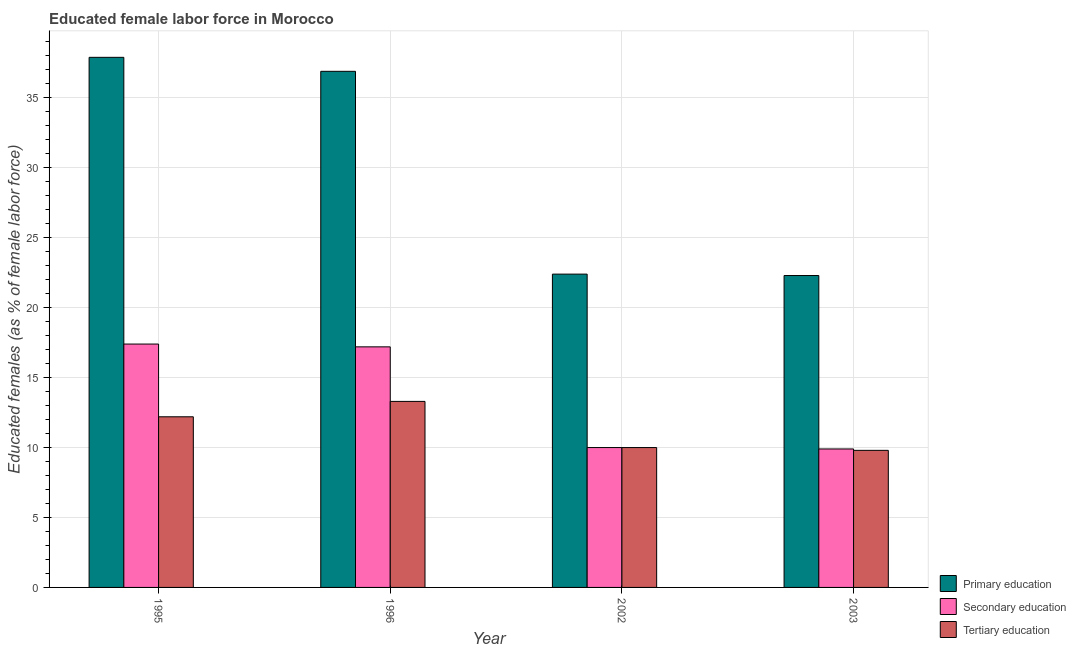How many different coloured bars are there?
Keep it short and to the point. 3. Are the number of bars on each tick of the X-axis equal?
Provide a succinct answer. Yes. How many bars are there on the 3rd tick from the left?
Provide a short and direct response. 3. In how many cases, is the number of bars for a given year not equal to the number of legend labels?
Provide a succinct answer. 0. What is the percentage of female labor force who received primary education in 1996?
Ensure brevity in your answer.  36.9. Across all years, what is the maximum percentage of female labor force who received tertiary education?
Provide a short and direct response. 13.3. Across all years, what is the minimum percentage of female labor force who received secondary education?
Give a very brief answer. 9.9. In which year was the percentage of female labor force who received tertiary education maximum?
Offer a very short reply. 1996. What is the total percentage of female labor force who received secondary education in the graph?
Your answer should be compact. 54.5. What is the difference between the percentage of female labor force who received tertiary education in 2002 and that in 2003?
Provide a succinct answer. 0.2. What is the difference between the percentage of female labor force who received primary education in 1996 and the percentage of female labor force who received secondary education in 2003?
Your response must be concise. 14.6. What is the average percentage of female labor force who received secondary education per year?
Give a very brief answer. 13.63. What is the ratio of the percentage of female labor force who received tertiary education in 1996 to that in 2003?
Offer a terse response. 1.36. Is the percentage of female labor force who received tertiary education in 1996 less than that in 2003?
Offer a terse response. No. What is the difference between the highest and the lowest percentage of female labor force who received secondary education?
Your answer should be compact. 7.5. In how many years, is the percentage of female labor force who received primary education greater than the average percentage of female labor force who received primary education taken over all years?
Offer a very short reply. 2. Is the sum of the percentage of female labor force who received primary education in 2002 and 2003 greater than the maximum percentage of female labor force who received tertiary education across all years?
Offer a terse response. Yes. What does the 3rd bar from the left in 2002 represents?
Your answer should be compact. Tertiary education. What does the 2nd bar from the right in 1996 represents?
Make the answer very short. Secondary education. How many bars are there?
Ensure brevity in your answer.  12. Does the graph contain grids?
Ensure brevity in your answer.  Yes. Where does the legend appear in the graph?
Your response must be concise. Bottom right. How are the legend labels stacked?
Ensure brevity in your answer.  Vertical. What is the title of the graph?
Give a very brief answer. Educated female labor force in Morocco. What is the label or title of the Y-axis?
Your answer should be very brief. Educated females (as % of female labor force). What is the Educated females (as % of female labor force) in Primary education in 1995?
Give a very brief answer. 37.9. What is the Educated females (as % of female labor force) of Secondary education in 1995?
Offer a terse response. 17.4. What is the Educated females (as % of female labor force) of Tertiary education in 1995?
Provide a short and direct response. 12.2. What is the Educated females (as % of female labor force) in Primary education in 1996?
Your answer should be compact. 36.9. What is the Educated females (as % of female labor force) of Secondary education in 1996?
Keep it short and to the point. 17.2. What is the Educated females (as % of female labor force) in Tertiary education in 1996?
Offer a terse response. 13.3. What is the Educated females (as % of female labor force) of Primary education in 2002?
Keep it short and to the point. 22.4. What is the Educated females (as % of female labor force) in Tertiary education in 2002?
Your answer should be very brief. 10. What is the Educated females (as % of female labor force) in Primary education in 2003?
Offer a very short reply. 22.3. What is the Educated females (as % of female labor force) of Secondary education in 2003?
Your answer should be very brief. 9.9. What is the Educated females (as % of female labor force) in Tertiary education in 2003?
Your answer should be very brief. 9.8. Across all years, what is the maximum Educated females (as % of female labor force) in Primary education?
Ensure brevity in your answer.  37.9. Across all years, what is the maximum Educated females (as % of female labor force) of Secondary education?
Offer a terse response. 17.4. Across all years, what is the maximum Educated females (as % of female labor force) of Tertiary education?
Keep it short and to the point. 13.3. Across all years, what is the minimum Educated females (as % of female labor force) of Primary education?
Provide a succinct answer. 22.3. Across all years, what is the minimum Educated females (as % of female labor force) of Secondary education?
Make the answer very short. 9.9. Across all years, what is the minimum Educated females (as % of female labor force) in Tertiary education?
Offer a terse response. 9.8. What is the total Educated females (as % of female labor force) in Primary education in the graph?
Provide a succinct answer. 119.5. What is the total Educated females (as % of female labor force) of Secondary education in the graph?
Give a very brief answer. 54.5. What is the total Educated females (as % of female labor force) in Tertiary education in the graph?
Your answer should be compact. 45.3. What is the difference between the Educated females (as % of female labor force) in Primary education in 1995 and that in 1996?
Give a very brief answer. 1. What is the difference between the Educated females (as % of female labor force) in Secondary education in 1995 and that in 1996?
Your answer should be very brief. 0.2. What is the difference between the Educated females (as % of female labor force) in Secondary education in 1995 and that in 2002?
Ensure brevity in your answer.  7.4. What is the difference between the Educated females (as % of female labor force) in Primary education in 1995 and that in 2003?
Ensure brevity in your answer.  15.6. What is the difference between the Educated females (as % of female labor force) of Primary education in 1996 and that in 2002?
Give a very brief answer. 14.5. What is the difference between the Educated females (as % of female labor force) of Primary education in 1995 and the Educated females (as % of female labor force) of Secondary education in 1996?
Ensure brevity in your answer.  20.7. What is the difference between the Educated females (as % of female labor force) of Primary education in 1995 and the Educated females (as % of female labor force) of Tertiary education in 1996?
Your response must be concise. 24.6. What is the difference between the Educated females (as % of female labor force) of Secondary education in 1995 and the Educated females (as % of female labor force) of Tertiary education in 1996?
Offer a terse response. 4.1. What is the difference between the Educated females (as % of female labor force) in Primary education in 1995 and the Educated females (as % of female labor force) in Secondary education in 2002?
Offer a very short reply. 27.9. What is the difference between the Educated females (as % of female labor force) of Primary education in 1995 and the Educated females (as % of female labor force) of Tertiary education in 2002?
Give a very brief answer. 27.9. What is the difference between the Educated females (as % of female labor force) in Secondary education in 1995 and the Educated females (as % of female labor force) in Tertiary education in 2002?
Your answer should be very brief. 7.4. What is the difference between the Educated females (as % of female labor force) of Primary education in 1995 and the Educated females (as % of female labor force) of Secondary education in 2003?
Make the answer very short. 28. What is the difference between the Educated females (as % of female labor force) in Primary education in 1995 and the Educated females (as % of female labor force) in Tertiary education in 2003?
Your answer should be compact. 28.1. What is the difference between the Educated females (as % of female labor force) in Secondary education in 1995 and the Educated females (as % of female labor force) in Tertiary education in 2003?
Your answer should be compact. 7.6. What is the difference between the Educated females (as % of female labor force) in Primary education in 1996 and the Educated females (as % of female labor force) in Secondary education in 2002?
Give a very brief answer. 26.9. What is the difference between the Educated females (as % of female labor force) in Primary education in 1996 and the Educated females (as % of female labor force) in Tertiary education in 2002?
Your answer should be very brief. 26.9. What is the difference between the Educated females (as % of female labor force) of Secondary education in 1996 and the Educated females (as % of female labor force) of Tertiary education in 2002?
Ensure brevity in your answer.  7.2. What is the difference between the Educated females (as % of female labor force) of Primary education in 1996 and the Educated females (as % of female labor force) of Secondary education in 2003?
Offer a very short reply. 27. What is the difference between the Educated females (as % of female labor force) in Primary education in 1996 and the Educated females (as % of female labor force) in Tertiary education in 2003?
Keep it short and to the point. 27.1. What is the average Educated females (as % of female labor force) in Primary education per year?
Offer a very short reply. 29.88. What is the average Educated females (as % of female labor force) in Secondary education per year?
Offer a very short reply. 13.62. What is the average Educated females (as % of female labor force) of Tertiary education per year?
Provide a succinct answer. 11.32. In the year 1995, what is the difference between the Educated females (as % of female labor force) of Primary education and Educated females (as % of female labor force) of Secondary education?
Your response must be concise. 20.5. In the year 1995, what is the difference between the Educated females (as % of female labor force) in Primary education and Educated females (as % of female labor force) in Tertiary education?
Make the answer very short. 25.7. In the year 1995, what is the difference between the Educated females (as % of female labor force) of Secondary education and Educated females (as % of female labor force) of Tertiary education?
Your response must be concise. 5.2. In the year 1996, what is the difference between the Educated females (as % of female labor force) in Primary education and Educated females (as % of female labor force) in Tertiary education?
Provide a succinct answer. 23.6. In the year 1996, what is the difference between the Educated females (as % of female labor force) in Secondary education and Educated females (as % of female labor force) in Tertiary education?
Ensure brevity in your answer.  3.9. What is the ratio of the Educated females (as % of female labor force) of Primary education in 1995 to that in 1996?
Provide a short and direct response. 1.03. What is the ratio of the Educated females (as % of female labor force) in Secondary education in 1995 to that in 1996?
Ensure brevity in your answer.  1.01. What is the ratio of the Educated females (as % of female labor force) in Tertiary education in 1995 to that in 1996?
Keep it short and to the point. 0.92. What is the ratio of the Educated females (as % of female labor force) of Primary education in 1995 to that in 2002?
Offer a very short reply. 1.69. What is the ratio of the Educated females (as % of female labor force) of Secondary education in 1995 to that in 2002?
Ensure brevity in your answer.  1.74. What is the ratio of the Educated females (as % of female labor force) in Tertiary education in 1995 to that in 2002?
Your answer should be very brief. 1.22. What is the ratio of the Educated females (as % of female labor force) of Primary education in 1995 to that in 2003?
Ensure brevity in your answer.  1.7. What is the ratio of the Educated females (as % of female labor force) of Secondary education in 1995 to that in 2003?
Your answer should be compact. 1.76. What is the ratio of the Educated females (as % of female labor force) in Tertiary education in 1995 to that in 2003?
Keep it short and to the point. 1.24. What is the ratio of the Educated females (as % of female labor force) of Primary education in 1996 to that in 2002?
Keep it short and to the point. 1.65. What is the ratio of the Educated females (as % of female labor force) in Secondary education in 1996 to that in 2002?
Offer a very short reply. 1.72. What is the ratio of the Educated females (as % of female labor force) in Tertiary education in 1996 to that in 2002?
Keep it short and to the point. 1.33. What is the ratio of the Educated females (as % of female labor force) in Primary education in 1996 to that in 2003?
Offer a terse response. 1.65. What is the ratio of the Educated females (as % of female labor force) of Secondary education in 1996 to that in 2003?
Provide a succinct answer. 1.74. What is the ratio of the Educated females (as % of female labor force) in Tertiary education in 1996 to that in 2003?
Provide a succinct answer. 1.36. What is the ratio of the Educated females (as % of female labor force) of Tertiary education in 2002 to that in 2003?
Your answer should be compact. 1.02. What is the difference between the highest and the second highest Educated females (as % of female labor force) in Primary education?
Make the answer very short. 1. What is the difference between the highest and the second highest Educated females (as % of female labor force) in Tertiary education?
Your answer should be very brief. 1.1. 